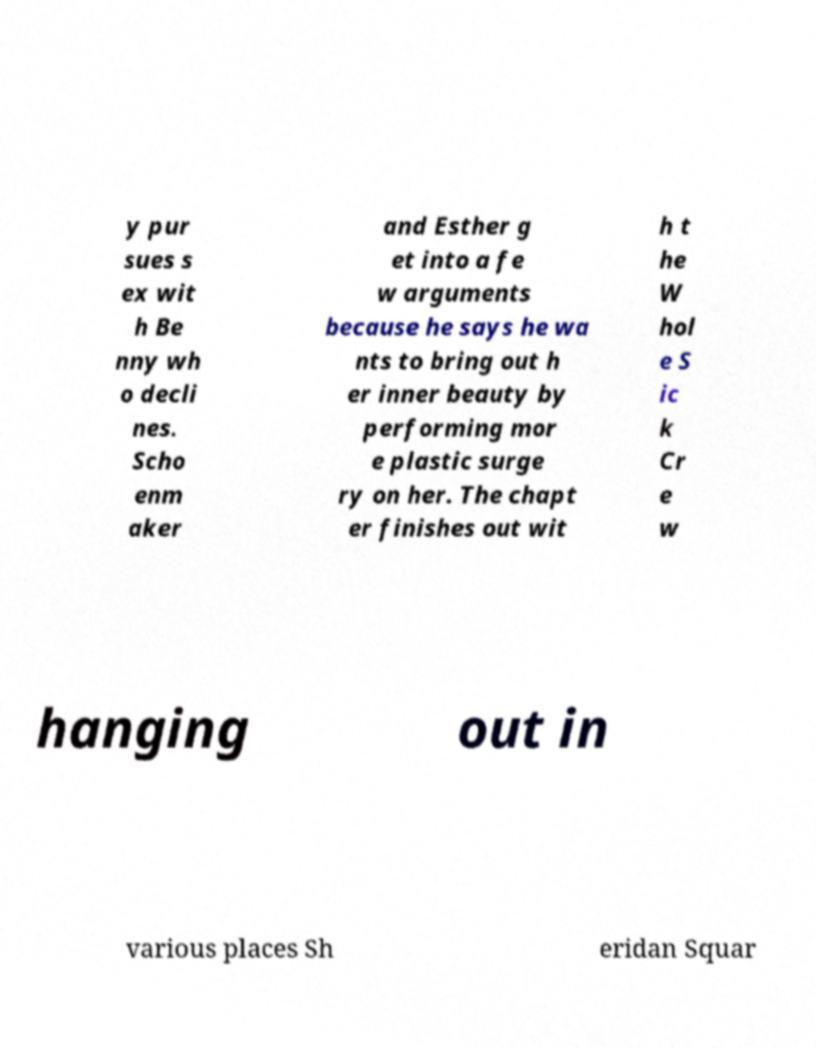Please identify and transcribe the text found in this image. y pur sues s ex wit h Be nny wh o decli nes. Scho enm aker and Esther g et into a fe w arguments because he says he wa nts to bring out h er inner beauty by performing mor e plastic surge ry on her. The chapt er finishes out wit h t he W hol e S ic k Cr e w hanging out in various places Sh eridan Squar 